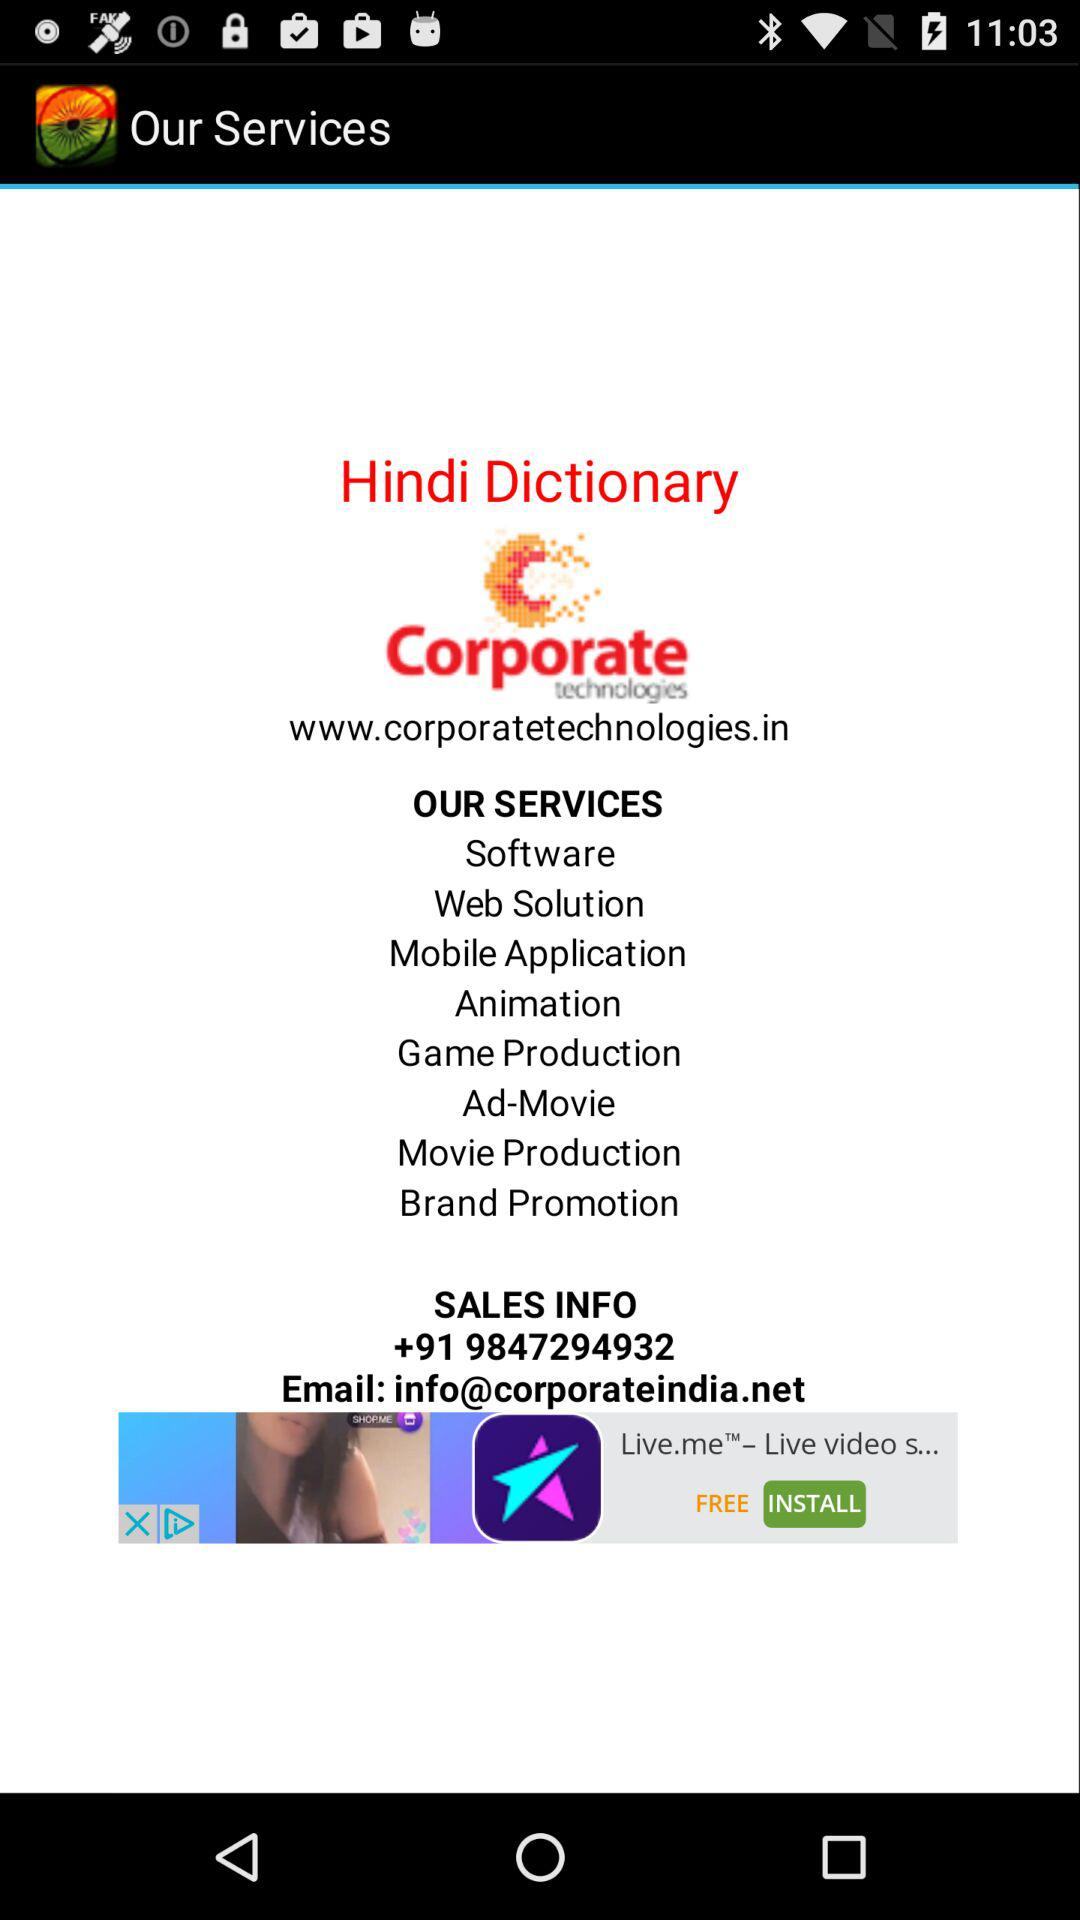How many services are offered by Corporate Technologies?
Answer the question using a single word or phrase. 8 